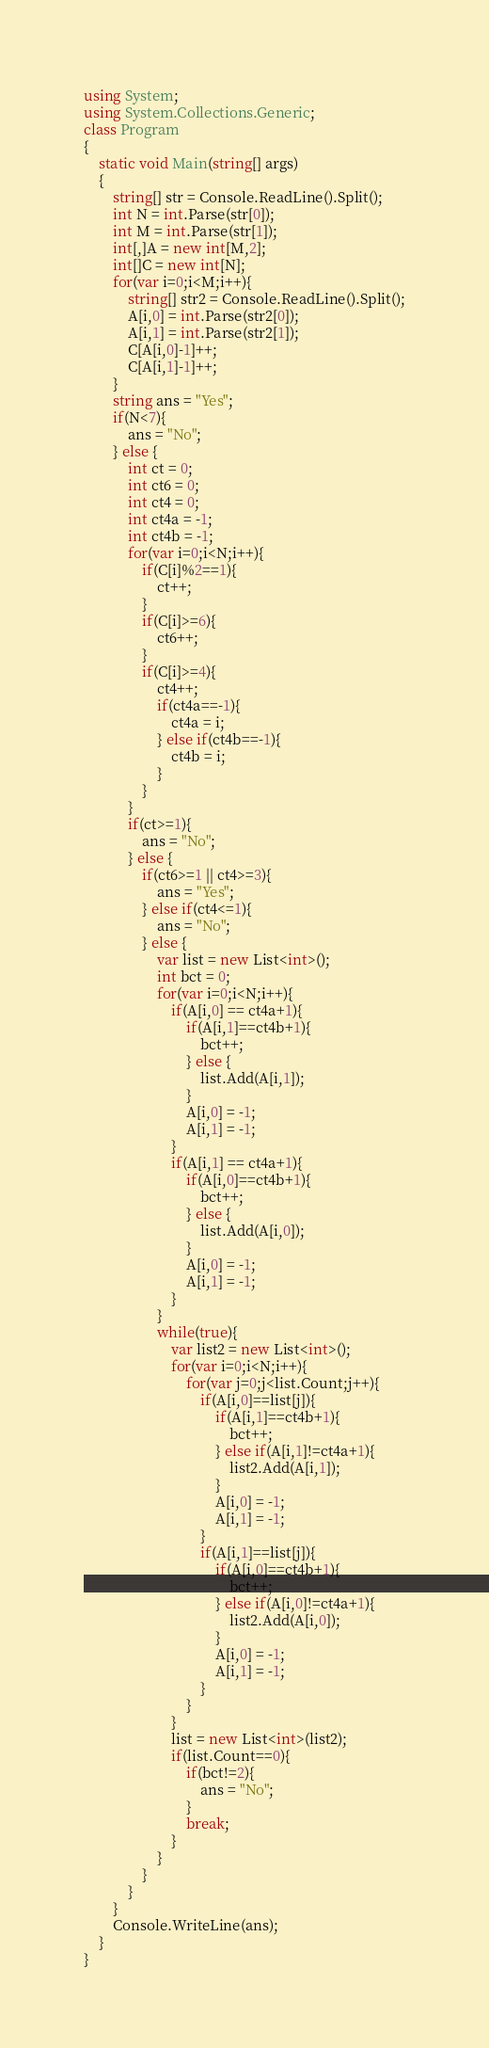<code> <loc_0><loc_0><loc_500><loc_500><_C#_>using System;
using System.Collections.Generic;
class Program
{
	static void Main(string[] args)
	{
		string[] str = Console.ReadLine().Split();
		int N = int.Parse(str[0]);
		int M = int.Parse(str[1]);
		int[,]A = new int[M,2];
		int[]C = new int[N];
		for(var i=0;i<M;i++){
			string[] str2 = Console.ReadLine().Split();
			A[i,0] = int.Parse(str2[0]);
			A[i,1] = int.Parse(str2[1]);
			C[A[i,0]-1]++;
			C[A[i,1]-1]++;
		}
		string ans = "Yes";
		if(N<7){
			ans = "No";
		} else {
			int ct = 0;
			int ct6 = 0;
			int ct4 = 0;
			int ct4a = -1;
			int ct4b = -1;
			for(var i=0;i<N;i++){
				if(C[i]%2==1){
					ct++;
				}
				if(C[i]>=6){
					ct6++;
				}
				if(C[i]>=4){
					ct4++;
					if(ct4a==-1){
						ct4a = i;
					} else if(ct4b==-1){
						ct4b = i;
					}
				}
			}
			if(ct>=1){
				ans = "No";
			} else {
				if(ct6>=1 || ct4>=3){
					ans = "Yes";
				} else if(ct4<=1){
					ans = "No";
				} else {
					var list = new List<int>();
					int bct = 0;
					for(var i=0;i<N;i++){
						if(A[i,0] == ct4a+1){
							if(A[i,1]==ct4b+1){
								bct++;
							} else {
								list.Add(A[i,1]);
							}
							A[i,0] = -1;
							A[i,1] = -1;
						}
						if(A[i,1] == ct4a+1){
							if(A[i,0]==ct4b+1){
								bct++;
							} else {
								list.Add(A[i,0]);
							}	
							A[i,0] = -1;
							A[i,1] = -1;
						}
					}
					while(true){
						var list2 = new List<int>();
						for(var i=0;i<N;i++){
							for(var j=0;j<list.Count;j++){
								if(A[i,0]==list[j]){
									if(A[i,1]==ct4b+1){
										bct++;
									} else if(A[i,1]!=ct4a+1){
										list2.Add(A[i,1]);
									}
									A[i,0] = -1;
									A[i,1] = -1;
								}
								if(A[i,1]==list[j]){
									if(A[i,0]==ct4b+1){
										bct++;
									} else if(A[i,0]!=ct4a+1){
										list2.Add(A[i,0]);
									}
									A[i,0] = -1;
									A[i,1] = -1;
								}
							}
						}
						list = new List<int>(list2);
						if(list.Count==0){
							if(bct!=2){
								ans = "No";
							}
							break;
						}
					}
				}
			}
		}
		Console.WriteLine(ans);
	}
}</code> 